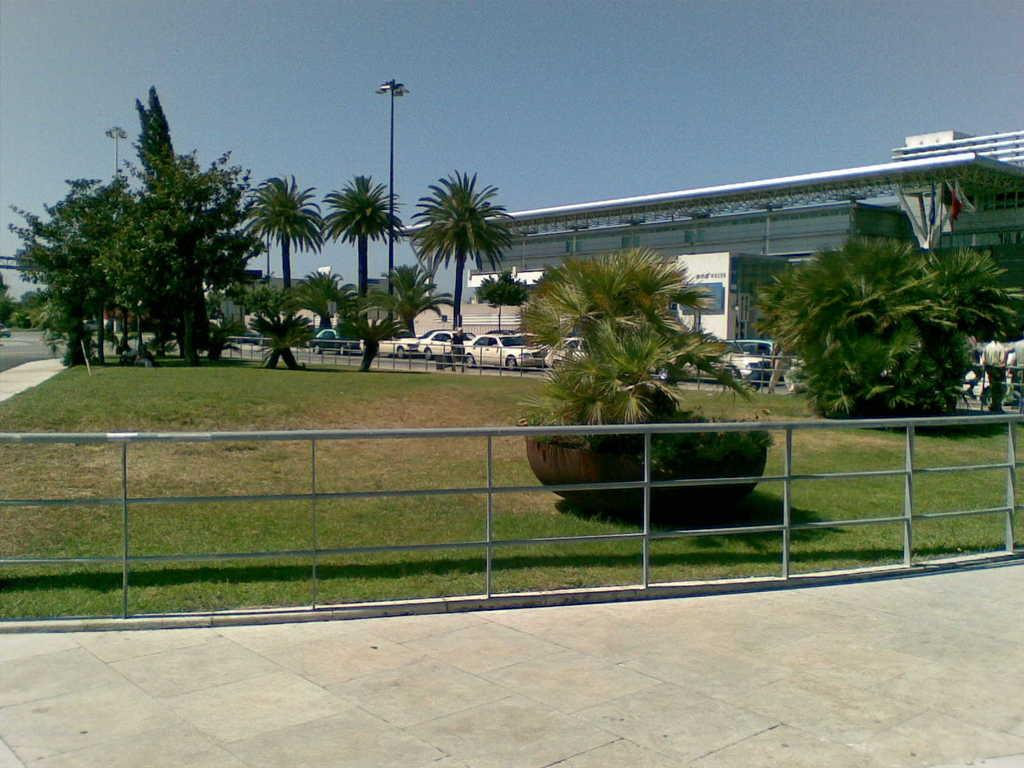What type of vegetation can be seen in the image? There are trees in the image. What else can be seen in the image besides trees? There are vehicles, buildings, grass, and people visible in the image. What is visible at the top of the image? The sky is visible at the top of the image. What type of bedroom can be seen in the image? There is no bedroom present in the image. Which direction is the image facing, towards the north? The image does not indicate a specific direction, and there is no reference to north. 